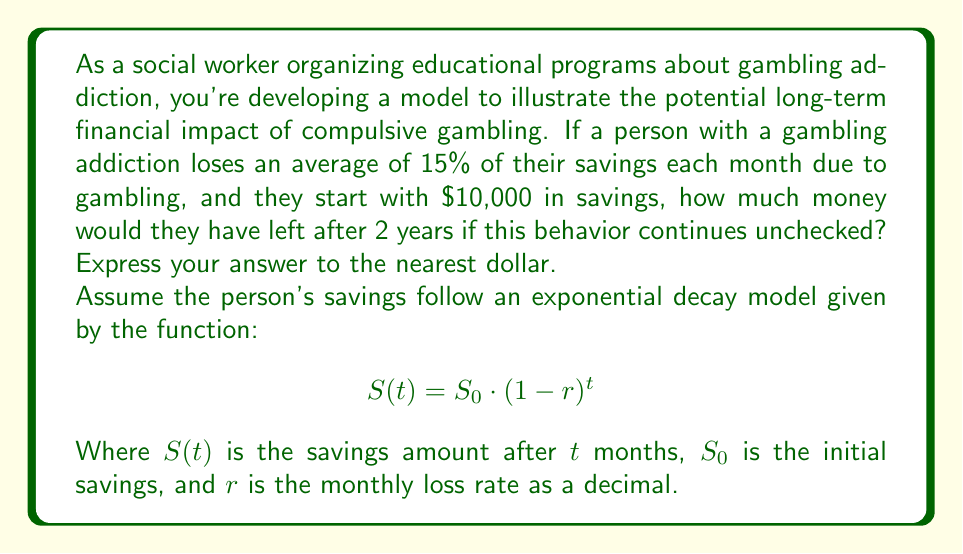Can you answer this question? To solve this problem, we'll use the exponential decay model provided:

$$S(t) = S_0 \cdot (1-r)^t$$

Given:
- Initial savings, $S_0 = \$10,000$
- Monthly loss rate, $r = 15\% = 0.15$
- Time period, $t = 2$ years = 24 months

Let's plug these values into the equation:

$$S(24) = 10000 \cdot (1-0.15)^{24}$$

Now, let's calculate step by step:

1) First, calculate $(1-0.15)$:
   $1 - 0.15 = 0.85$

2) Now, we need to calculate $0.85^{24}$:
   $0.85^{24} \approx 0.0214$ (rounded to 4 decimal places)

3) Finally, multiply this by the initial savings:
   $10000 \cdot 0.0214 = 214$

Therefore, after 2 years of losing 15% of savings each month, the person would have approximately $214 left.

This dramatic decrease illustrates the devastating financial impact of compulsive gambling over time, emphasizing the importance of early intervention and support for those affected by gambling addiction.
Answer: $214 